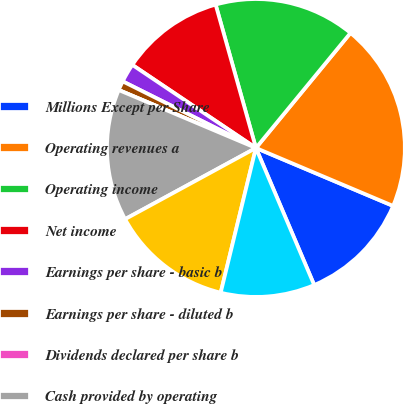<chart> <loc_0><loc_0><loc_500><loc_500><pie_chart><fcel>Millions Except per Share<fcel>Operating revenues a<fcel>Operating income<fcel>Net income<fcel>Earnings per share - basic b<fcel>Earnings per share - diluted b<fcel>Dividends declared per share b<fcel>Cash provided by operating<fcel>Cash used in investing<fcel>Cash used in financing<nl><fcel>12.24%<fcel>20.41%<fcel>15.31%<fcel>11.22%<fcel>2.04%<fcel>1.02%<fcel>0.0%<fcel>14.29%<fcel>13.27%<fcel>10.2%<nl></chart> 